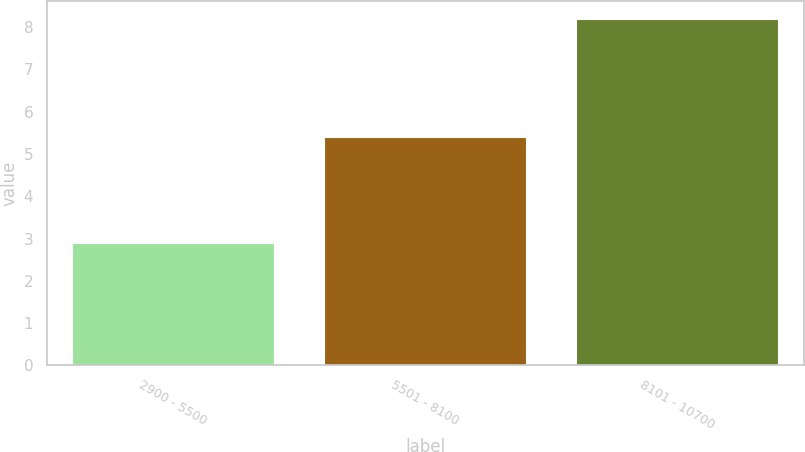Convert chart to OTSL. <chart><loc_0><loc_0><loc_500><loc_500><bar_chart><fcel>2900 - 5500<fcel>5501 - 8100<fcel>8101 - 10700<nl><fcel>2.9<fcel>5.4<fcel>8.2<nl></chart> 